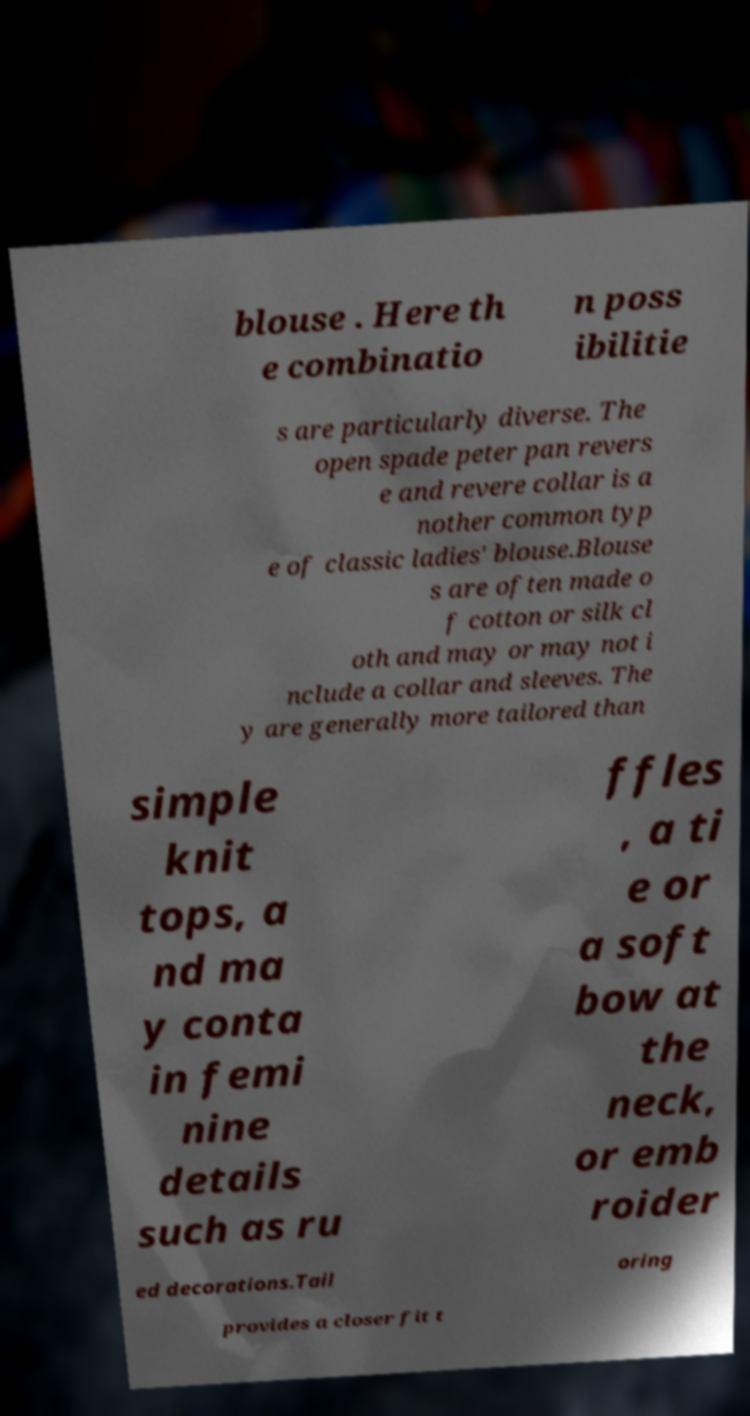Could you assist in decoding the text presented in this image and type it out clearly? blouse . Here th e combinatio n poss ibilitie s are particularly diverse. The open spade peter pan revers e and revere collar is a nother common typ e of classic ladies' blouse.Blouse s are often made o f cotton or silk cl oth and may or may not i nclude a collar and sleeves. The y are generally more tailored than simple knit tops, a nd ma y conta in femi nine details such as ru ffles , a ti e or a soft bow at the neck, or emb roider ed decorations.Tail oring provides a closer fit t 